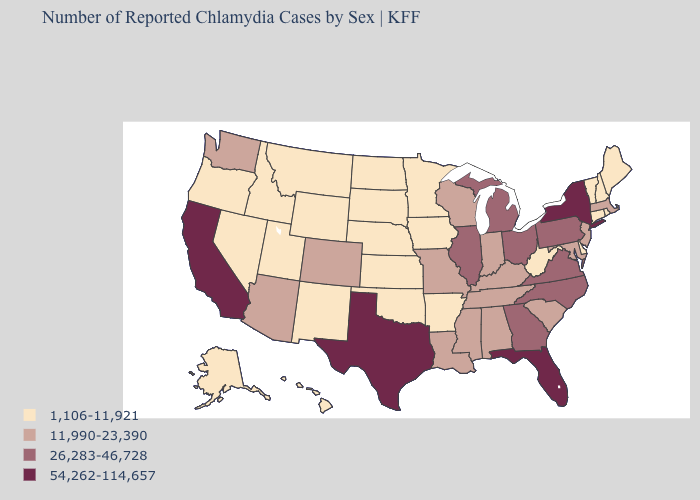Is the legend a continuous bar?
Short answer required. No. Name the states that have a value in the range 11,990-23,390?
Answer briefly. Alabama, Arizona, Colorado, Indiana, Kentucky, Louisiana, Maryland, Massachusetts, Mississippi, Missouri, New Jersey, South Carolina, Tennessee, Washington, Wisconsin. What is the value of Washington?
Quick response, please. 11,990-23,390. Which states hav the highest value in the MidWest?
Keep it brief. Illinois, Michigan, Ohio. Name the states that have a value in the range 54,262-114,657?
Answer briefly. California, Florida, New York, Texas. Does Oregon have the highest value in the USA?
Keep it brief. No. Name the states that have a value in the range 1,106-11,921?
Give a very brief answer. Alaska, Arkansas, Connecticut, Delaware, Hawaii, Idaho, Iowa, Kansas, Maine, Minnesota, Montana, Nebraska, Nevada, New Hampshire, New Mexico, North Dakota, Oklahoma, Oregon, Rhode Island, South Dakota, Utah, Vermont, West Virginia, Wyoming. Is the legend a continuous bar?
Short answer required. No. Among the states that border Idaho , does Washington have the lowest value?
Keep it brief. No. Which states hav the highest value in the Northeast?
Answer briefly. New York. Which states hav the highest value in the West?
Keep it brief. California. What is the value of South Carolina?
Give a very brief answer. 11,990-23,390. Does Texas have the highest value in the South?
Be succinct. Yes. What is the lowest value in the USA?
Give a very brief answer. 1,106-11,921. Name the states that have a value in the range 11,990-23,390?
Be succinct. Alabama, Arizona, Colorado, Indiana, Kentucky, Louisiana, Maryland, Massachusetts, Mississippi, Missouri, New Jersey, South Carolina, Tennessee, Washington, Wisconsin. 